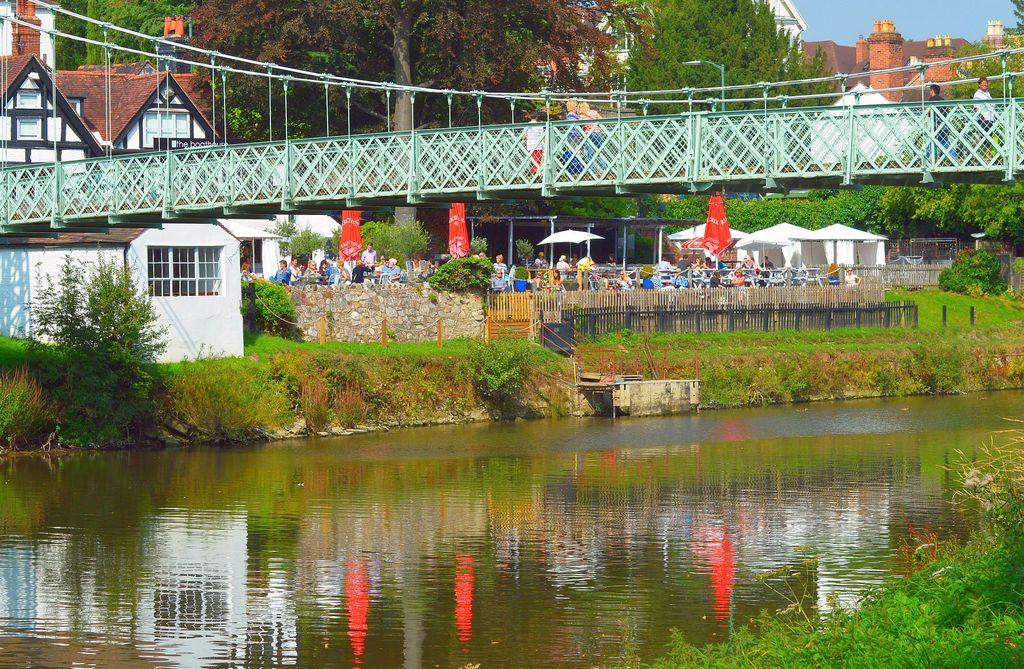What type of vegetation can be seen in the image? There are plants and grass visible in the image. What is the body of water in the image used for? The water visible in the image is used for recreational purposes, as indicated by the presence of a bridge. What type of barrier is present in the image? There is a fence in the image. What type of structure is present in the image? There is a bridge in the image. What type of shelter is present in the image? There are tents in the image. What type of buildings are present in the image? There are buildings in the image. What type of vegetation is present in the image? There are trees in the image. What is visible at the top of the image? The sky is visible at the top of the image. What time of day is it in the image? The time of day cannot be determined from the image alone. What type of structure is the umbrella used for in the image? The umbrella is not used for any structure in the image; it is likely used for shade or protection from the elements. 